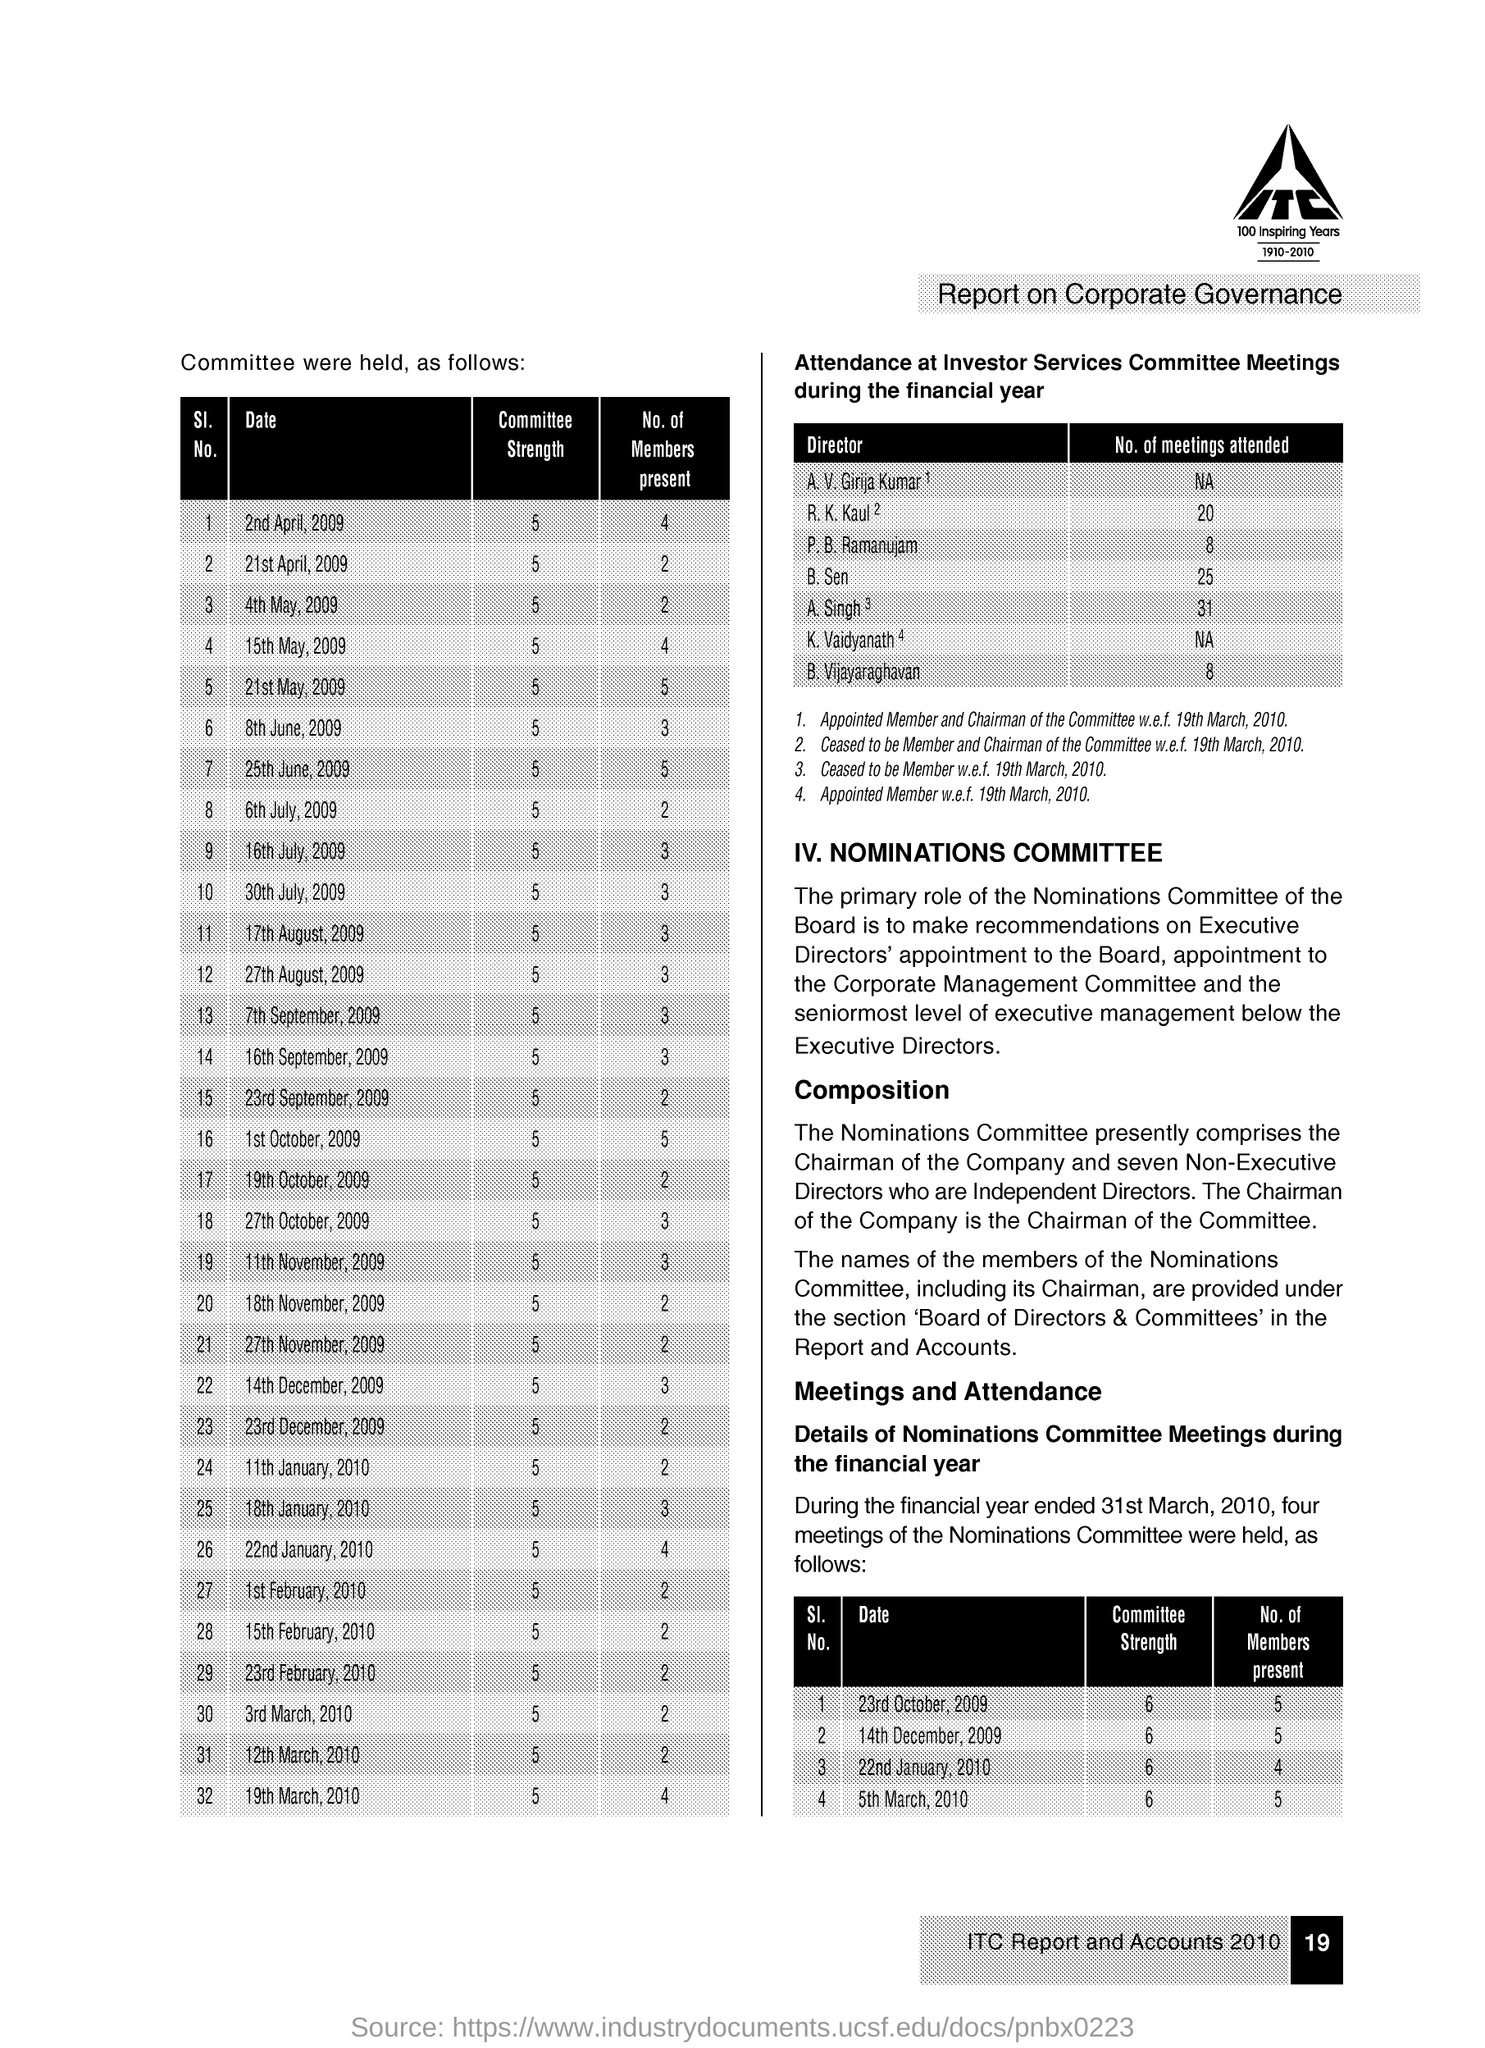What is the number of present members of 30th July 2009?
Provide a succinct answer. 3. What is the committee strength of 2nd April 2009?
Give a very brief answer. 5. What is the number of meetings attended by B Vijayaraghavan?
Your answer should be very brief. 8. 